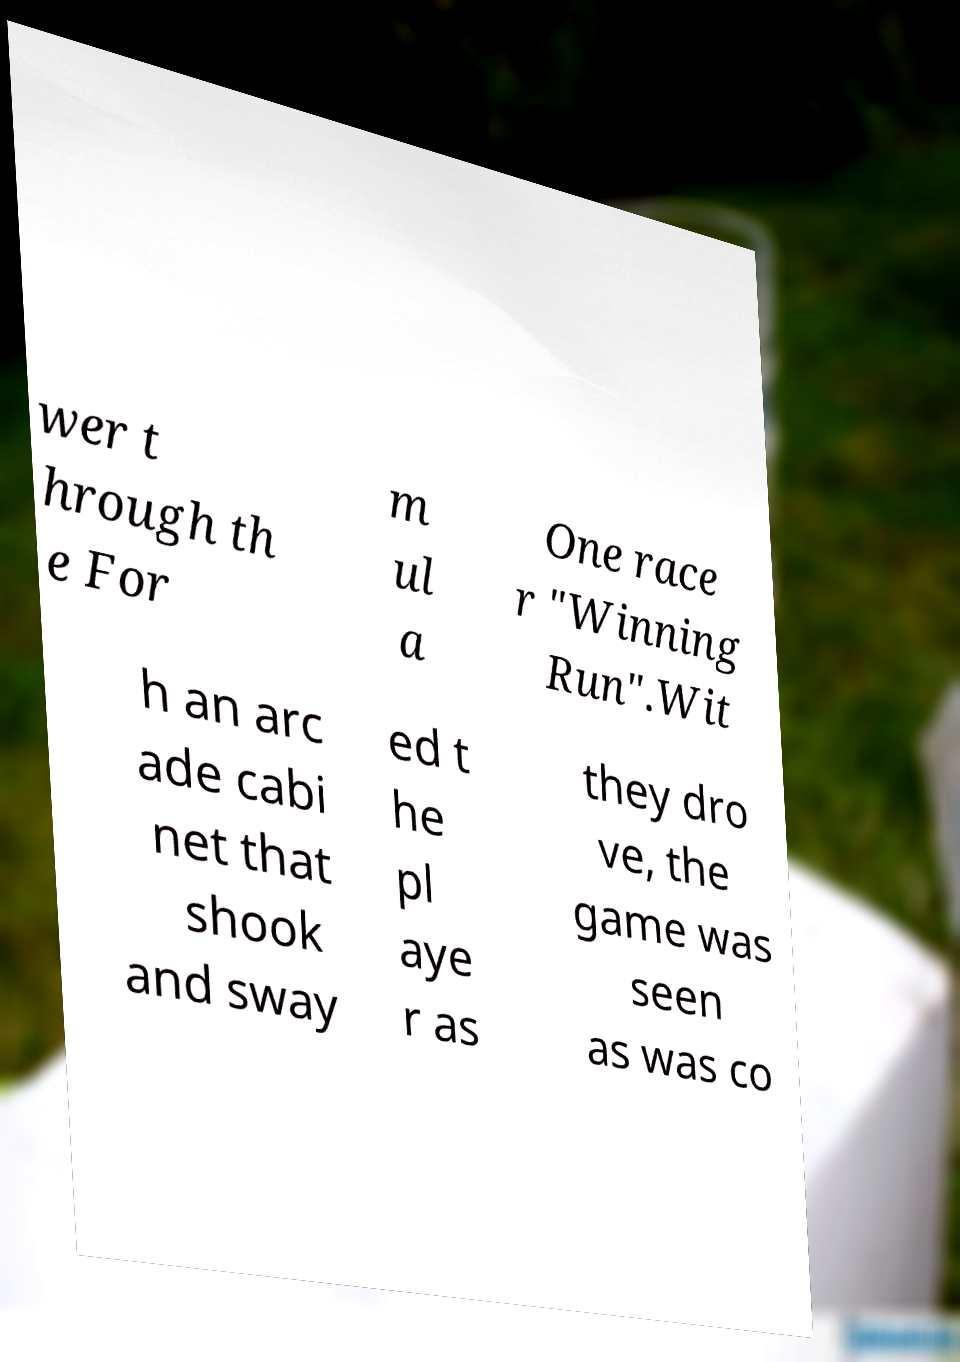There's text embedded in this image that I need extracted. Can you transcribe it verbatim? wer t hrough th e For m ul a One race r "Winning Run".Wit h an arc ade cabi net that shook and sway ed t he pl aye r as they dro ve, the game was seen as was co 